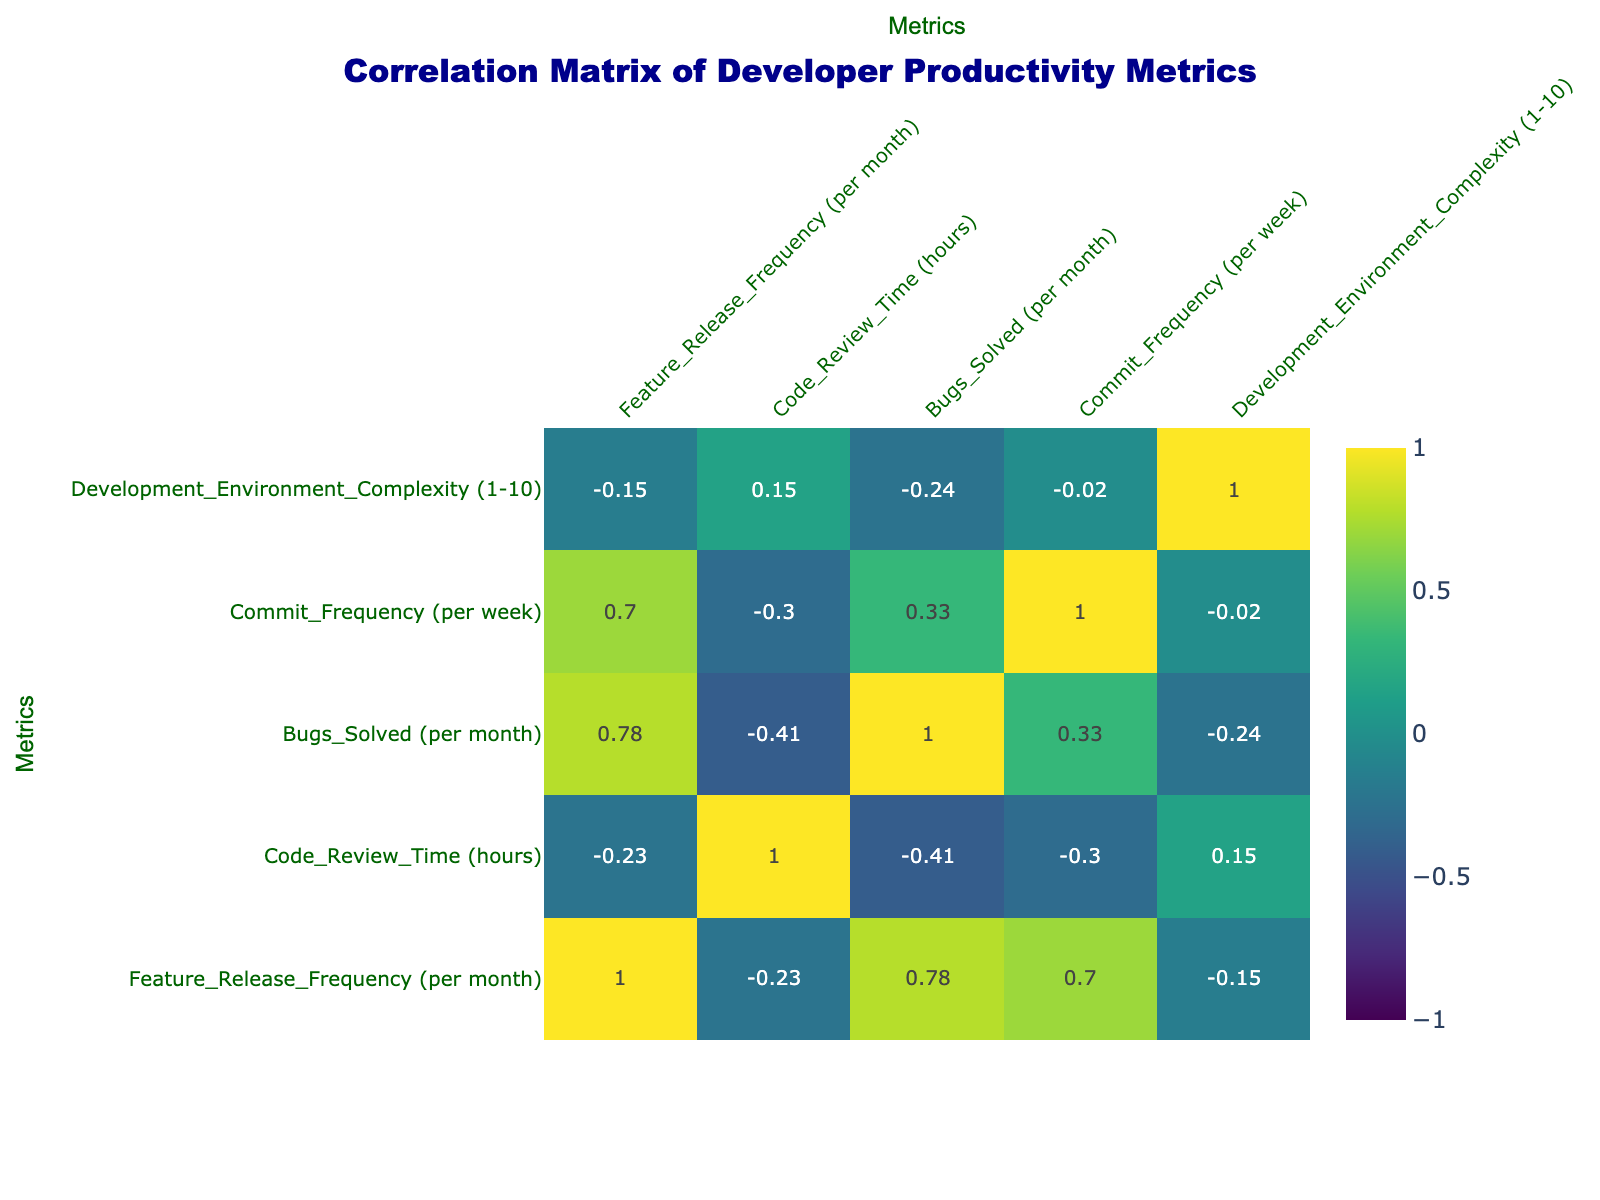What is the maximum feature release frequency among the developers? From the table, the feature release frequencies are: 3, 5, 7, 4, 6, 2, 5, 3, 6, and 4. The maximum value from this list is 7.
Answer: 7 Which developer solved the most bugs per month? In the data, the bugs solved per month are: 15, 20, 25, 18, 22, 10, 15, 20, 30, and 16. The highest number is 30, which corresponds to Isabella Martinez.
Answer: Isabella Martinez What is the average code review time among the developers? The code review times in hours are: 4, 3, 5, 2, 6, 7, 3, 4, 2, and 5. Summing these values gives 4 + 3 + 5 + 2 + 6 + 7 + 3 + 4 + 2 + 5 = 41. There are 10 developers, so the average is 41 divided by 10, which equals 4.1.
Answer: 4.1 Is there a negative correlation between commit frequency and code review time? Looking at the correlation matrix, if the value is less than zero, it indicates a negative correlation. The correlation between commit frequency and code review time is -0.48, which is indeed negative.
Answer: Yes What is the difference in bugs solved between the developers who release features at the highest and lowest frequency? The developer with the highest feature release frequency is Cathy Brown, solving 25 bugs per month. The lowest frequency is Frank White with 10 bugs solved per month. Hence, the difference is 25 - 10 = 15.
Answer: 15 Which two developers have the highest and lowest development environment complexity? From the table, Alice Johnson has a complexity of 6 (highest) and Frank White has 8 (lowest). Comparing these values, we confirm Alice Johnson has the highest complexity and Frank White the lowest.
Answer: Alice Johnson and Frank White What percentage of developers solved more than 20 bugs per month? There are three developers who solved more than 20 bugs: Cathy Brown (25), Eva Green (22), and Isabella Martinez (30). Out of 10 developers, this is 3 out of 10, which is 30%, calculated as (3/10) * 100.
Answer: 30% Does an increase in feature release frequency always relate to more bugs solved per month? Examining the data, as feature release frequency increases (e.g., Frank White at 2 fixes 10 bugs while Cathy Brown at 7 fixes 25 bugs), the trend suggests that more frequent releases correlate to more bugs solved. However, it isn't strictly proportional, indicating variability.
Answer: No 